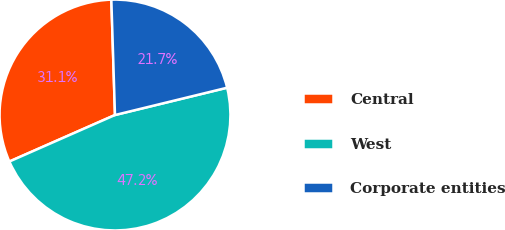<chart> <loc_0><loc_0><loc_500><loc_500><pie_chart><fcel>Central<fcel>West<fcel>Corporate entities<nl><fcel>31.1%<fcel>47.2%<fcel>21.7%<nl></chart> 